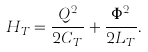<formula> <loc_0><loc_0><loc_500><loc_500>H _ { T } = \frac { Q ^ { 2 } } { 2 C _ { T } } + \frac { \Phi ^ { 2 } } { 2 L _ { T } } .</formula> 